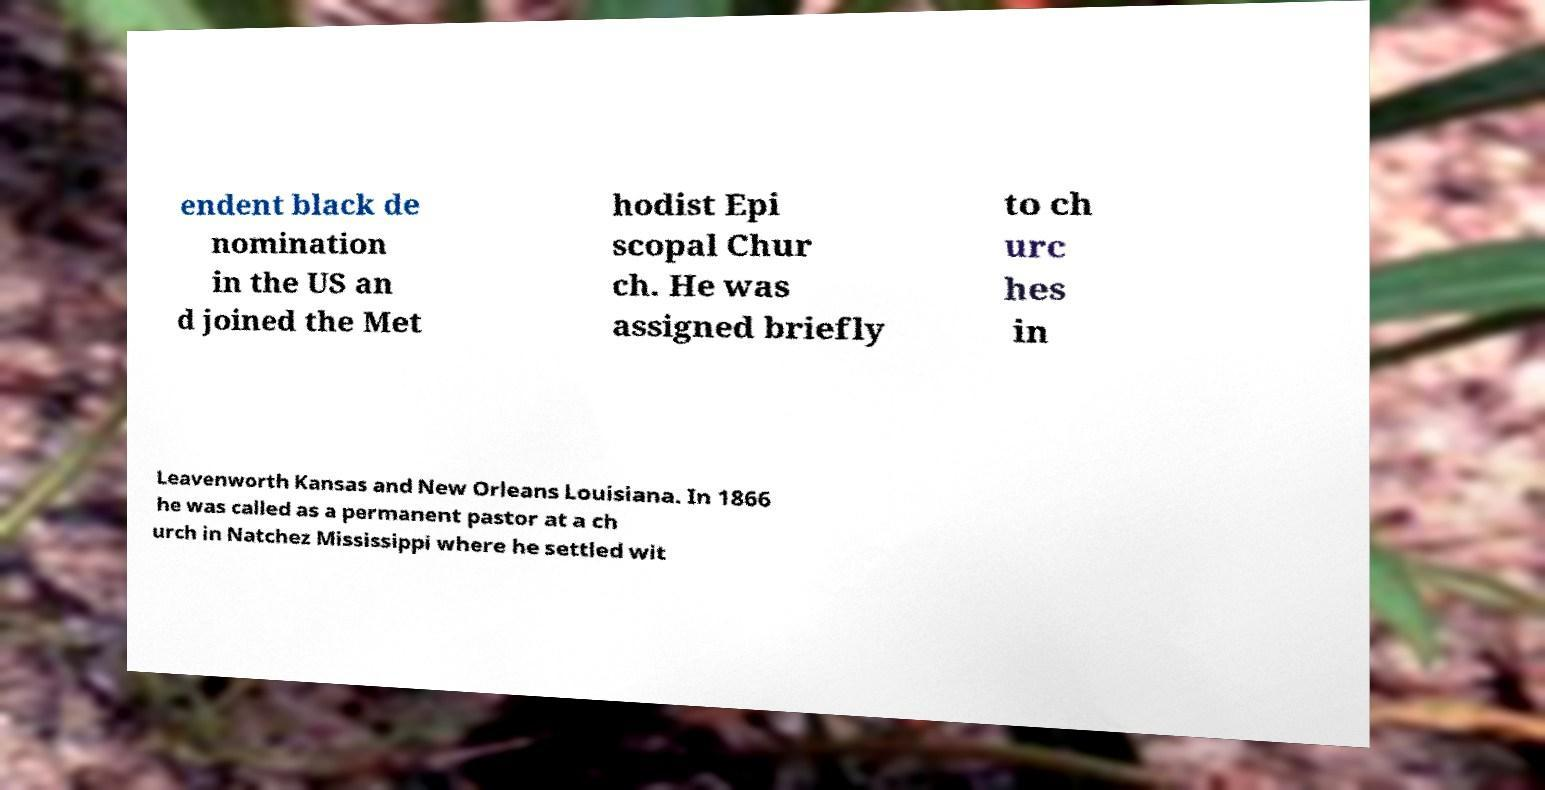Could you assist in decoding the text presented in this image and type it out clearly? endent black de nomination in the US an d joined the Met hodist Epi scopal Chur ch. He was assigned briefly to ch urc hes in Leavenworth Kansas and New Orleans Louisiana. In 1866 he was called as a permanent pastor at a ch urch in Natchez Mississippi where he settled wit 